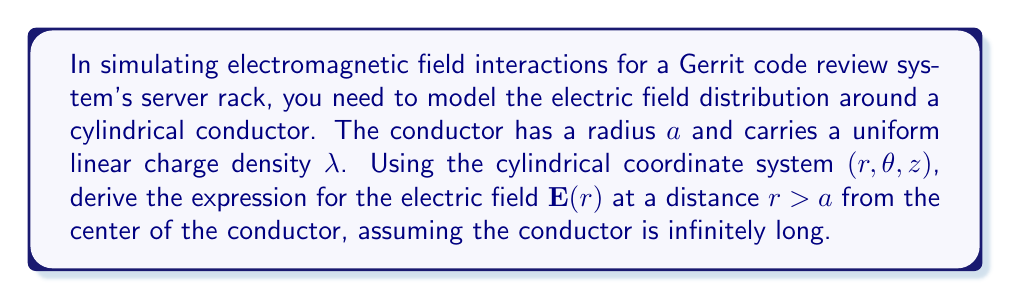Provide a solution to this math problem. To solve this problem, we'll use Gauss's law and the symmetry of the system. Let's break it down step-by-step:

1) First, we recognize that due to the cylindrical symmetry of the problem, the electric field will only depend on the radial distance $r$ and will point radially outward.

2) We can write the electric field as:
   $$\mathbf{E}(r) = E(r)\hat{r}$$
   where $\hat{r}$ is the unit vector in the radial direction.

3) Now, let's apply Gauss's law. We choose a Gaussian surface as a cylinder of radius $r$ and height $h$ coaxial with the conductor. Gauss's law states:
   $$\oint \mathbf{E} \cdot d\mathbf{A} = \frac{Q_{enc}}{\epsilon_0}$$

4) The enclosed charge is:
   $$Q_{enc} = \lambda h$$

5) Due to symmetry, $\mathbf{E}$ is constant over the curved surface of our Gaussian cylinder, and perpendicular to the top and bottom surfaces. So the left side of Gauss's law becomes:
   $$\oint \mathbf{E} \cdot d\mathbf{A} = E(r) \cdot 2\pi r h$$

6) Substituting these into Gauss's law:
   $$E(r) \cdot 2\pi r h = \frac{\lambda h}{\epsilon_0}$$

7) Solving for $E(r)$:
   $$E(r) = \frac{\lambda}{2\pi\epsilon_0 r}$$

8) Therefore, the vector form of the electric field is:
   $$\mathbf{E}(r) = \frac{\lambda}{2\pi\epsilon_0 r}\hat{r}$$

This expression is valid for $r > a$, where $a$ is the radius of the cylindrical conductor.
Answer: $$\mathbf{E}(r) = \frac{\lambda}{2\pi\epsilon_0 r}\hat{r}$$ 